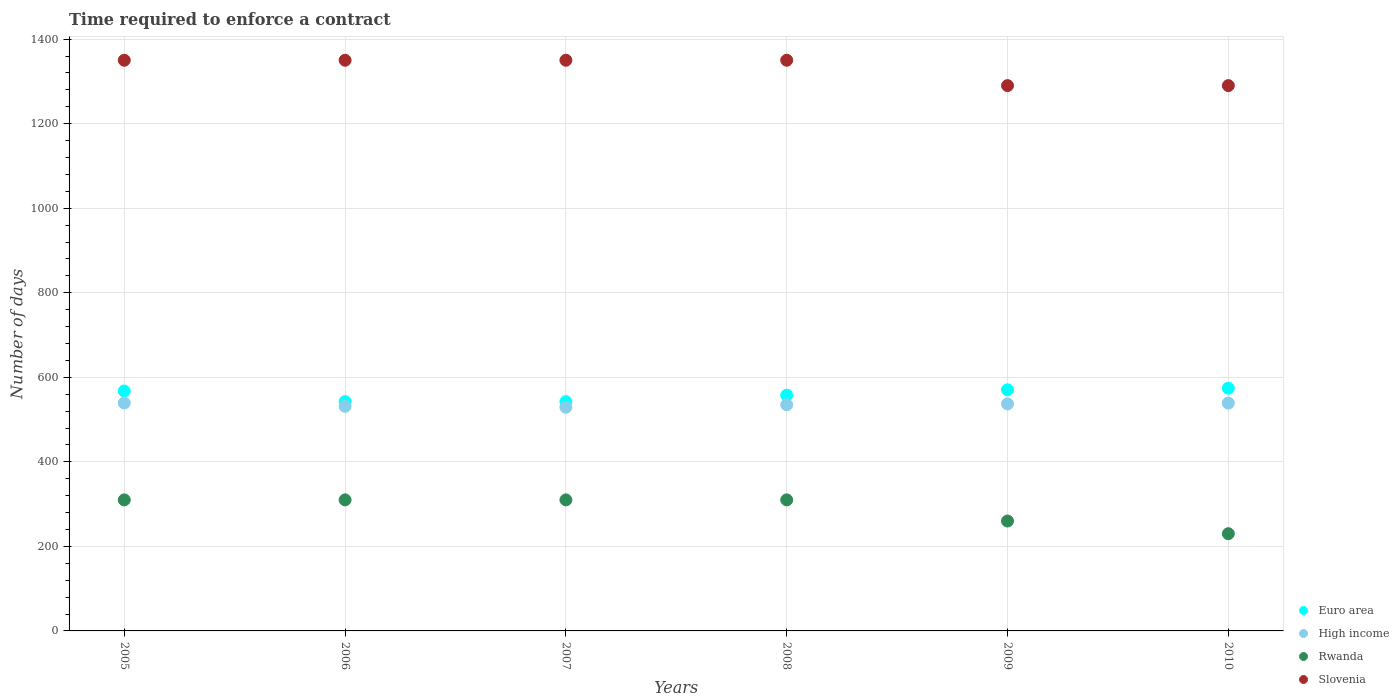Is the number of dotlines equal to the number of legend labels?
Provide a succinct answer. Yes. What is the number of days required to enforce a contract in Euro area in 2008?
Offer a terse response. 557.61. Across all years, what is the maximum number of days required to enforce a contract in Euro area?
Offer a very short reply. 574.28. Across all years, what is the minimum number of days required to enforce a contract in Euro area?
Ensure brevity in your answer.  542.41. In which year was the number of days required to enforce a contract in Rwanda minimum?
Your response must be concise. 2010. What is the total number of days required to enforce a contract in Rwanda in the graph?
Make the answer very short. 1730. What is the difference between the number of days required to enforce a contract in High income in 2005 and that in 2010?
Offer a very short reply. 0.27. What is the difference between the number of days required to enforce a contract in High income in 2010 and the number of days required to enforce a contract in Slovenia in 2008?
Make the answer very short. -811.04. What is the average number of days required to enforce a contract in Rwanda per year?
Offer a very short reply. 288.33. In the year 2006, what is the difference between the number of days required to enforce a contract in Euro area and number of days required to enforce a contract in Slovenia?
Give a very brief answer. -807.59. What is the ratio of the number of days required to enforce a contract in Euro area in 2009 to that in 2010?
Ensure brevity in your answer.  0.99. Is the difference between the number of days required to enforce a contract in Euro area in 2006 and 2010 greater than the difference between the number of days required to enforce a contract in Slovenia in 2006 and 2010?
Offer a very short reply. No. What is the difference between the highest and the second highest number of days required to enforce a contract in Euro area?
Your response must be concise. 3.89. What is the difference between the highest and the lowest number of days required to enforce a contract in Rwanda?
Provide a succinct answer. 80. In how many years, is the number of days required to enforce a contract in Slovenia greater than the average number of days required to enforce a contract in Slovenia taken over all years?
Give a very brief answer. 4. Is it the case that in every year, the sum of the number of days required to enforce a contract in Slovenia and number of days required to enforce a contract in Rwanda  is greater than the sum of number of days required to enforce a contract in Euro area and number of days required to enforce a contract in High income?
Give a very brief answer. No. Is the number of days required to enforce a contract in Rwanda strictly less than the number of days required to enforce a contract in High income over the years?
Offer a very short reply. Yes. What is the difference between two consecutive major ticks on the Y-axis?
Provide a succinct answer. 200. Are the values on the major ticks of Y-axis written in scientific E-notation?
Your response must be concise. No. Does the graph contain grids?
Keep it short and to the point. Yes. Where does the legend appear in the graph?
Provide a succinct answer. Bottom right. How many legend labels are there?
Provide a short and direct response. 4. How are the legend labels stacked?
Keep it short and to the point. Vertical. What is the title of the graph?
Ensure brevity in your answer.  Time required to enforce a contract. What is the label or title of the Y-axis?
Offer a very short reply. Number of days. What is the Number of days in Euro area in 2005?
Provide a succinct answer. 567.5. What is the Number of days in High income in 2005?
Give a very brief answer. 539.23. What is the Number of days of Rwanda in 2005?
Offer a terse response. 310. What is the Number of days in Slovenia in 2005?
Provide a succinct answer. 1350. What is the Number of days of Euro area in 2006?
Your answer should be very brief. 542.41. What is the Number of days in High income in 2006?
Give a very brief answer. 531.28. What is the Number of days in Rwanda in 2006?
Offer a terse response. 310. What is the Number of days in Slovenia in 2006?
Ensure brevity in your answer.  1350. What is the Number of days of Euro area in 2007?
Offer a very short reply. 542.41. What is the Number of days in High income in 2007?
Ensure brevity in your answer.  529.17. What is the Number of days in Rwanda in 2007?
Provide a short and direct response. 310. What is the Number of days of Slovenia in 2007?
Your response must be concise. 1350. What is the Number of days of Euro area in 2008?
Provide a succinct answer. 557.61. What is the Number of days in High income in 2008?
Your response must be concise. 535.04. What is the Number of days in Rwanda in 2008?
Ensure brevity in your answer.  310. What is the Number of days in Slovenia in 2008?
Offer a very short reply. 1350. What is the Number of days of Euro area in 2009?
Provide a short and direct response. 570.39. What is the Number of days in High income in 2009?
Offer a very short reply. 537.11. What is the Number of days of Rwanda in 2009?
Provide a succinct answer. 260. What is the Number of days in Slovenia in 2009?
Give a very brief answer. 1290. What is the Number of days of Euro area in 2010?
Provide a short and direct response. 574.28. What is the Number of days in High income in 2010?
Your answer should be compact. 538.96. What is the Number of days in Rwanda in 2010?
Ensure brevity in your answer.  230. What is the Number of days in Slovenia in 2010?
Your answer should be very brief. 1290. Across all years, what is the maximum Number of days of Euro area?
Make the answer very short. 574.28. Across all years, what is the maximum Number of days in High income?
Your answer should be compact. 539.23. Across all years, what is the maximum Number of days in Rwanda?
Provide a succinct answer. 310. Across all years, what is the maximum Number of days of Slovenia?
Ensure brevity in your answer.  1350. Across all years, what is the minimum Number of days of Euro area?
Keep it short and to the point. 542.41. Across all years, what is the minimum Number of days in High income?
Provide a succinct answer. 529.17. Across all years, what is the minimum Number of days of Rwanda?
Give a very brief answer. 230. Across all years, what is the minimum Number of days in Slovenia?
Provide a short and direct response. 1290. What is the total Number of days of Euro area in the graph?
Provide a succinct answer. 3354.6. What is the total Number of days in High income in the graph?
Give a very brief answer. 3210.79. What is the total Number of days of Rwanda in the graph?
Offer a very short reply. 1730. What is the total Number of days in Slovenia in the graph?
Give a very brief answer. 7980. What is the difference between the Number of days of Euro area in 2005 and that in 2006?
Provide a short and direct response. 25.09. What is the difference between the Number of days of High income in 2005 and that in 2006?
Make the answer very short. 7.95. What is the difference between the Number of days in Rwanda in 2005 and that in 2006?
Offer a very short reply. 0. What is the difference between the Number of days in Euro area in 2005 and that in 2007?
Make the answer very short. 25.09. What is the difference between the Number of days of High income in 2005 and that in 2007?
Your answer should be compact. 10.06. What is the difference between the Number of days in Rwanda in 2005 and that in 2007?
Offer a very short reply. 0. What is the difference between the Number of days of Slovenia in 2005 and that in 2007?
Your answer should be very brief. 0. What is the difference between the Number of days in Euro area in 2005 and that in 2008?
Provide a short and direct response. 9.89. What is the difference between the Number of days in High income in 2005 and that in 2008?
Ensure brevity in your answer.  4.19. What is the difference between the Number of days of Rwanda in 2005 and that in 2008?
Your answer should be compact. 0. What is the difference between the Number of days in Euro area in 2005 and that in 2009?
Your answer should be very brief. -2.89. What is the difference between the Number of days in High income in 2005 and that in 2009?
Provide a succinct answer. 2.12. What is the difference between the Number of days in Slovenia in 2005 and that in 2009?
Make the answer very short. 60. What is the difference between the Number of days in Euro area in 2005 and that in 2010?
Keep it short and to the point. -6.78. What is the difference between the Number of days in High income in 2005 and that in 2010?
Give a very brief answer. 0.27. What is the difference between the Number of days in Euro area in 2006 and that in 2007?
Provide a succinct answer. 0. What is the difference between the Number of days in High income in 2006 and that in 2007?
Make the answer very short. 2.11. What is the difference between the Number of days of Euro area in 2006 and that in 2008?
Offer a very short reply. -15.2. What is the difference between the Number of days of High income in 2006 and that in 2008?
Your response must be concise. -3.76. What is the difference between the Number of days of Slovenia in 2006 and that in 2008?
Your answer should be very brief. 0. What is the difference between the Number of days in Euro area in 2006 and that in 2009?
Provide a succinct answer. -27.98. What is the difference between the Number of days of High income in 2006 and that in 2009?
Your answer should be very brief. -5.83. What is the difference between the Number of days in Euro area in 2006 and that in 2010?
Keep it short and to the point. -31.87. What is the difference between the Number of days in High income in 2006 and that in 2010?
Offer a very short reply. -7.68. What is the difference between the Number of days in Euro area in 2007 and that in 2008?
Provide a succinct answer. -15.2. What is the difference between the Number of days in High income in 2007 and that in 2008?
Offer a terse response. -5.87. What is the difference between the Number of days of Slovenia in 2007 and that in 2008?
Your answer should be very brief. 0. What is the difference between the Number of days in Euro area in 2007 and that in 2009?
Offer a terse response. -27.98. What is the difference between the Number of days of High income in 2007 and that in 2009?
Your answer should be compact. -7.94. What is the difference between the Number of days in Slovenia in 2007 and that in 2009?
Offer a terse response. 60. What is the difference between the Number of days of Euro area in 2007 and that in 2010?
Offer a very short reply. -31.87. What is the difference between the Number of days of High income in 2007 and that in 2010?
Ensure brevity in your answer.  -9.79. What is the difference between the Number of days of Slovenia in 2007 and that in 2010?
Provide a short and direct response. 60. What is the difference between the Number of days in Euro area in 2008 and that in 2009?
Provide a short and direct response. -12.78. What is the difference between the Number of days in High income in 2008 and that in 2009?
Give a very brief answer. -2.07. What is the difference between the Number of days in Rwanda in 2008 and that in 2009?
Your answer should be very brief. 50. What is the difference between the Number of days in Slovenia in 2008 and that in 2009?
Your response must be concise. 60. What is the difference between the Number of days of Euro area in 2008 and that in 2010?
Your answer should be compact. -16.67. What is the difference between the Number of days of High income in 2008 and that in 2010?
Your answer should be very brief. -3.93. What is the difference between the Number of days of Euro area in 2009 and that in 2010?
Ensure brevity in your answer.  -3.89. What is the difference between the Number of days of High income in 2009 and that in 2010?
Keep it short and to the point. -1.85. What is the difference between the Number of days in Rwanda in 2009 and that in 2010?
Give a very brief answer. 30. What is the difference between the Number of days in Euro area in 2005 and the Number of days in High income in 2006?
Give a very brief answer. 36.22. What is the difference between the Number of days of Euro area in 2005 and the Number of days of Rwanda in 2006?
Ensure brevity in your answer.  257.5. What is the difference between the Number of days in Euro area in 2005 and the Number of days in Slovenia in 2006?
Your answer should be very brief. -782.5. What is the difference between the Number of days in High income in 2005 and the Number of days in Rwanda in 2006?
Your answer should be compact. 229.23. What is the difference between the Number of days of High income in 2005 and the Number of days of Slovenia in 2006?
Offer a very short reply. -810.77. What is the difference between the Number of days of Rwanda in 2005 and the Number of days of Slovenia in 2006?
Offer a very short reply. -1040. What is the difference between the Number of days of Euro area in 2005 and the Number of days of High income in 2007?
Provide a succinct answer. 38.33. What is the difference between the Number of days in Euro area in 2005 and the Number of days in Rwanda in 2007?
Ensure brevity in your answer.  257.5. What is the difference between the Number of days of Euro area in 2005 and the Number of days of Slovenia in 2007?
Your response must be concise. -782.5. What is the difference between the Number of days of High income in 2005 and the Number of days of Rwanda in 2007?
Ensure brevity in your answer.  229.23. What is the difference between the Number of days of High income in 2005 and the Number of days of Slovenia in 2007?
Ensure brevity in your answer.  -810.77. What is the difference between the Number of days in Rwanda in 2005 and the Number of days in Slovenia in 2007?
Ensure brevity in your answer.  -1040. What is the difference between the Number of days of Euro area in 2005 and the Number of days of High income in 2008?
Offer a terse response. 32.46. What is the difference between the Number of days of Euro area in 2005 and the Number of days of Rwanda in 2008?
Provide a succinct answer. 257.5. What is the difference between the Number of days in Euro area in 2005 and the Number of days in Slovenia in 2008?
Keep it short and to the point. -782.5. What is the difference between the Number of days of High income in 2005 and the Number of days of Rwanda in 2008?
Provide a short and direct response. 229.23. What is the difference between the Number of days of High income in 2005 and the Number of days of Slovenia in 2008?
Provide a short and direct response. -810.77. What is the difference between the Number of days of Rwanda in 2005 and the Number of days of Slovenia in 2008?
Ensure brevity in your answer.  -1040. What is the difference between the Number of days in Euro area in 2005 and the Number of days in High income in 2009?
Offer a terse response. 30.39. What is the difference between the Number of days in Euro area in 2005 and the Number of days in Rwanda in 2009?
Your answer should be very brief. 307.5. What is the difference between the Number of days in Euro area in 2005 and the Number of days in Slovenia in 2009?
Provide a short and direct response. -722.5. What is the difference between the Number of days in High income in 2005 and the Number of days in Rwanda in 2009?
Provide a short and direct response. 279.23. What is the difference between the Number of days in High income in 2005 and the Number of days in Slovenia in 2009?
Provide a succinct answer. -750.77. What is the difference between the Number of days of Rwanda in 2005 and the Number of days of Slovenia in 2009?
Keep it short and to the point. -980. What is the difference between the Number of days of Euro area in 2005 and the Number of days of High income in 2010?
Your response must be concise. 28.54. What is the difference between the Number of days of Euro area in 2005 and the Number of days of Rwanda in 2010?
Your answer should be very brief. 337.5. What is the difference between the Number of days of Euro area in 2005 and the Number of days of Slovenia in 2010?
Give a very brief answer. -722.5. What is the difference between the Number of days of High income in 2005 and the Number of days of Rwanda in 2010?
Your response must be concise. 309.23. What is the difference between the Number of days of High income in 2005 and the Number of days of Slovenia in 2010?
Provide a succinct answer. -750.77. What is the difference between the Number of days in Rwanda in 2005 and the Number of days in Slovenia in 2010?
Ensure brevity in your answer.  -980. What is the difference between the Number of days in Euro area in 2006 and the Number of days in High income in 2007?
Offer a terse response. 13.24. What is the difference between the Number of days in Euro area in 2006 and the Number of days in Rwanda in 2007?
Make the answer very short. 232.41. What is the difference between the Number of days of Euro area in 2006 and the Number of days of Slovenia in 2007?
Your answer should be very brief. -807.59. What is the difference between the Number of days in High income in 2006 and the Number of days in Rwanda in 2007?
Make the answer very short. 221.28. What is the difference between the Number of days in High income in 2006 and the Number of days in Slovenia in 2007?
Provide a short and direct response. -818.72. What is the difference between the Number of days of Rwanda in 2006 and the Number of days of Slovenia in 2007?
Your response must be concise. -1040. What is the difference between the Number of days of Euro area in 2006 and the Number of days of High income in 2008?
Your answer should be very brief. 7.37. What is the difference between the Number of days of Euro area in 2006 and the Number of days of Rwanda in 2008?
Your response must be concise. 232.41. What is the difference between the Number of days in Euro area in 2006 and the Number of days in Slovenia in 2008?
Make the answer very short. -807.59. What is the difference between the Number of days of High income in 2006 and the Number of days of Rwanda in 2008?
Give a very brief answer. 221.28. What is the difference between the Number of days in High income in 2006 and the Number of days in Slovenia in 2008?
Your answer should be compact. -818.72. What is the difference between the Number of days of Rwanda in 2006 and the Number of days of Slovenia in 2008?
Offer a terse response. -1040. What is the difference between the Number of days of Euro area in 2006 and the Number of days of High income in 2009?
Offer a very short reply. 5.3. What is the difference between the Number of days in Euro area in 2006 and the Number of days in Rwanda in 2009?
Provide a succinct answer. 282.41. What is the difference between the Number of days of Euro area in 2006 and the Number of days of Slovenia in 2009?
Give a very brief answer. -747.59. What is the difference between the Number of days of High income in 2006 and the Number of days of Rwanda in 2009?
Ensure brevity in your answer.  271.28. What is the difference between the Number of days in High income in 2006 and the Number of days in Slovenia in 2009?
Make the answer very short. -758.72. What is the difference between the Number of days in Rwanda in 2006 and the Number of days in Slovenia in 2009?
Ensure brevity in your answer.  -980. What is the difference between the Number of days in Euro area in 2006 and the Number of days in High income in 2010?
Offer a very short reply. 3.45. What is the difference between the Number of days of Euro area in 2006 and the Number of days of Rwanda in 2010?
Keep it short and to the point. 312.41. What is the difference between the Number of days in Euro area in 2006 and the Number of days in Slovenia in 2010?
Make the answer very short. -747.59. What is the difference between the Number of days in High income in 2006 and the Number of days in Rwanda in 2010?
Offer a terse response. 301.28. What is the difference between the Number of days of High income in 2006 and the Number of days of Slovenia in 2010?
Offer a terse response. -758.72. What is the difference between the Number of days of Rwanda in 2006 and the Number of days of Slovenia in 2010?
Offer a very short reply. -980. What is the difference between the Number of days in Euro area in 2007 and the Number of days in High income in 2008?
Make the answer very short. 7.37. What is the difference between the Number of days of Euro area in 2007 and the Number of days of Rwanda in 2008?
Offer a very short reply. 232.41. What is the difference between the Number of days of Euro area in 2007 and the Number of days of Slovenia in 2008?
Offer a terse response. -807.59. What is the difference between the Number of days of High income in 2007 and the Number of days of Rwanda in 2008?
Your response must be concise. 219.17. What is the difference between the Number of days of High income in 2007 and the Number of days of Slovenia in 2008?
Offer a very short reply. -820.83. What is the difference between the Number of days in Rwanda in 2007 and the Number of days in Slovenia in 2008?
Provide a short and direct response. -1040. What is the difference between the Number of days of Euro area in 2007 and the Number of days of High income in 2009?
Provide a short and direct response. 5.3. What is the difference between the Number of days of Euro area in 2007 and the Number of days of Rwanda in 2009?
Provide a short and direct response. 282.41. What is the difference between the Number of days in Euro area in 2007 and the Number of days in Slovenia in 2009?
Keep it short and to the point. -747.59. What is the difference between the Number of days of High income in 2007 and the Number of days of Rwanda in 2009?
Offer a very short reply. 269.17. What is the difference between the Number of days of High income in 2007 and the Number of days of Slovenia in 2009?
Your answer should be very brief. -760.83. What is the difference between the Number of days in Rwanda in 2007 and the Number of days in Slovenia in 2009?
Your answer should be compact. -980. What is the difference between the Number of days of Euro area in 2007 and the Number of days of High income in 2010?
Make the answer very short. 3.45. What is the difference between the Number of days in Euro area in 2007 and the Number of days in Rwanda in 2010?
Give a very brief answer. 312.41. What is the difference between the Number of days in Euro area in 2007 and the Number of days in Slovenia in 2010?
Make the answer very short. -747.59. What is the difference between the Number of days in High income in 2007 and the Number of days in Rwanda in 2010?
Your response must be concise. 299.17. What is the difference between the Number of days of High income in 2007 and the Number of days of Slovenia in 2010?
Your answer should be very brief. -760.83. What is the difference between the Number of days in Rwanda in 2007 and the Number of days in Slovenia in 2010?
Offer a terse response. -980. What is the difference between the Number of days in Euro area in 2008 and the Number of days in High income in 2009?
Make the answer very short. 20.5. What is the difference between the Number of days in Euro area in 2008 and the Number of days in Rwanda in 2009?
Give a very brief answer. 297.61. What is the difference between the Number of days of Euro area in 2008 and the Number of days of Slovenia in 2009?
Ensure brevity in your answer.  -732.39. What is the difference between the Number of days of High income in 2008 and the Number of days of Rwanda in 2009?
Make the answer very short. 275.04. What is the difference between the Number of days in High income in 2008 and the Number of days in Slovenia in 2009?
Make the answer very short. -754.96. What is the difference between the Number of days of Rwanda in 2008 and the Number of days of Slovenia in 2009?
Your response must be concise. -980. What is the difference between the Number of days in Euro area in 2008 and the Number of days in High income in 2010?
Provide a succinct answer. 18.65. What is the difference between the Number of days in Euro area in 2008 and the Number of days in Rwanda in 2010?
Give a very brief answer. 327.61. What is the difference between the Number of days in Euro area in 2008 and the Number of days in Slovenia in 2010?
Provide a succinct answer. -732.39. What is the difference between the Number of days in High income in 2008 and the Number of days in Rwanda in 2010?
Provide a short and direct response. 305.04. What is the difference between the Number of days of High income in 2008 and the Number of days of Slovenia in 2010?
Make the answer very short. -754.96. What is the difference between the Number of days of Rwanda in 2008 and the Number of days of Slovenia in 2010?
Provide a short and direct response. -980. What is the difference between the Number of days in Euro area in 2009 and the Number of days in High income in 2010?
Give a very brief answer. 31.43. What is the difference between the Number of days in Euro area in 2009 and the Number of days in Rwanda in 2010?
Offer a terse response. 340.39. What is the difference between the Number of days of Euro area in 2009 and the Number of days of Slovenia in 2010?
Make the answer very short. -719.61. What is the difference between the Number of days of High income in 2009 and the Number of days of Rwanda in 2010?
Offer a terse response. 307.11. What is the difference between the Number of days of High income in 2009 and the Number of days of Slovenia in 2010?
Offer a very short reply. -752.89. What is the difference between the Number of days in Rwanda in 2009 and the Number of days in Slovenia in 2010?
Make the answer very short. -1030. What is the average Number of days in Euro area per year?
Make the answer very short. 559.1. What is the average Number of days of High income per year?
Offer a very short reply. 535.13. What is the average Number of days in Rwanda per year?
Your answer should be compact. 288.33. What is the average Number of days of Slovenia per year?
Offer a very short reply. 1330. In the year 2005, what is the difference between the Number of days of Euro area and Number of days of High income?
Your answer should be very brief. 28.27. In the year 2005, what is the difference between the Number of days in Euro area and Number of days in Rwanda?
Provide a succinct answer. 257.5. In the year 2005, what is the difference between the Number of days in Euro area and Number of days in Slovenia?
Ensure brevity in your answer.  -782.5. In the year 2005, what is the difference between the Number of days of High income and Number of days of Rwanda?
Keep it short and to the point. 229.23. In the year 2005, what is the difference between the Number of days in High income and Number of days in Slovenia?
Provide a short and direct response. -810.77. In the year 2005, what is the difference between the Number of days in Rwanda and Number of days in Slovenia?
Give a very brief answer. -1040. In the year 2006, what is the difference between the Number of days in Euro area and Number of days in High income?
Ensure brevity in your answer.  11.13. In the year 2006, what is the difference between the Number of days of Euro area and Number of days of Rwanda?
Provide a short and direct response. 232.41. In the year 2006, what is the difference between the Number of days of Euro area and Number of days of Slovenia?
Offer a very short reply. -807.59. In the year 2006, what is the difference between the Number of days of High income and Number of days of Rwanda?
Offer a terse response. 221.28. In the year 2006, what is the difference between the Number of days in High income and Number of days in Slovenia?
Offer a very short reply. -818.72. In the year 2006, what is the difference between the Number of days of Rwanda and Number of days of Slovenia?
Your response must be concise. -1040. In the year 2007, what is the difference between the Number of days of Euro area and Number of days of High income?
Give a very brief answer. 13.24. In the year 2007, what is the difference between the Number of days of Euro area and Number of days of Rwanda?
Keep it short and to the point. 232.41. In the year 2007, what is the difference between the Number of days of Euro area and Number of days of Slovenia?
Offer a very short reply. -807.59. In the year 2007, what is the difference between the Number of days in High income and Number of days in Rwanda?
Give a very brief answer. 219.17. In the year 2007, what is the difference between the Number of days in High income and Number of days in Slovenia?
Provide a short and direct response. -820.83. In the year 2007, what is the difference between the Number of days in Rwanda and Number of days in Slovenia?
Your response must be concise. -1040. In the year 2008, what is the difference between the Number of days of Euro area and Number of days of High income?
Make the answer very short. 22.57. In the year 2008, what is the difference between the Number of days of Euro area and Number of days of Rwanda?
Offer a terse response. 247.61. In the year 2008, what is the difference between the Number of days in Euro area and Number of days in Slovenia?
Ensure brevity in your answer.  -792.39. In the year 2008, what is the difference between the Number of days in High income and Number of days in Rwanda?
Provide a succinct answer. 225.04. In the year 2008, what is the difference between the Number of days of High income and Number of days of Slovenia?
Provide a short and direct response. -814.96. In the year 2008, what is the difference between the Number of days of Rwanda and Number of days of Slovenia?
Provide a succinct answer. -1040. In the year 2009, what is the difference between the Number of days of Euro area and Number of days of High income?
Provide a succinct answer. 33.28. In the year 2009, what is the difference between the Number of days of Euro area and Number of days of Rwanda?
Keep it short and to the point. 310.39. In the year 2009, what is the difference between the Number of days of Euro area and Number of days of Slovenia?
Keep it short and to the point. -719.61. In the year 2009, what is the difference between the Number of days in High income and Number of days in Rwanda?
Offer a very short reply. 277.11. In the year 2009, what is the difference between the Number of days of High income and Number of days of Slovenia?
Ensure brevity in your answer.  -752.89. In the year 2009, what is the difference between the Number of days in Rwanda and Number of days in Slovenia?
Ensure brevity in your answer.  -1030. In the year 2010, what is the difference between the Number of days of Euro area and Number of days of High income?
Ensure brevity in your answer.  35.31. In the year 2010, what is the difference between the Number of days in Euro area and Number of days in Rwanda?
Offer a very short reply. 344.28. In the year 2010, what is the difference between the Number of days in Euro area and Number of days in Slovenia?
Provide a short and direct response. -715.72. In the year 2010, what is the difference between the Number of days of High income and Number of days of Rwanda?
Ensure brevity in your answer.  308.96. In the year 2010, what is the difference between the Number of days in High income and Number of days in Slovenia?
Offer a terse response. -751.04. In the year 2010, what is the difference between the Number of days in Rwanda and Number of days in Slovenia?
Your response must be concise. -1060. What is the ratio of the Number of days in Euro area in 2005 to that in 2006?
Your response must be concise. 1.05. What is the ratio of the Number of days in Slovenia in 2005 to that in 2006?
Keep it short and to the point. 1. What is the ratio of the Number of days in Euro area in 2005 to that in 2007?
Ensure brevity in your answer.  1.05. What is the ratio of the Number of days in Rwanda in 2005 to that in 2007?
Ensure brevity in your answer.  1. What is the ratio of the Number of days of Euro area in 2005 to that in 2008?
Provide a short and direct response. 1.02. What is the ratio of the Number of days of High income in 2005 to that in 2008?
Offer a terse response. 1.01. What is the ratio of the Number of days of Rwanda in 2005 to that in 2008?
Offer a very short reply. 1. What is the ratio of the Number of days in Slovenia in 2005 to that in 2008?
Your answer should be very brief. 1. What is the ratio of the Number of days in Rwanda in 2005 to that in 2009?
Offer a terse response. 1.19. What is the ratio of the Number of days of Slovenia in 2005 to that in 2009?
Provide a succinct answer. 1.05. What is the ratio of the Number of days in High income in 2005 to that in 2010?
Make the answer very short. 1. What is the ratio of the Number of days in Rwanda in 2005 to that in 2010?
Provide a succinct answer. 1.35. What is the ratio of the Number of days in Slovenia in 2005 to that in 2010?
Your answer should be very brief. 1.05. What is the ratio of the Number of days of High income in 2006 to that in 2007?
Provide a succinct answer. 1. What is the ratio of the Number of days of Euro area in 2006 to that in 2008?
Give a very brief answer. 0.97. What is the ratio of the Number of days of High income in 2006 to that in 2008?
Make the answer very short. 0.99. What is the ratio of the Number of days in Rwanda in 2006 to that in 2008?
Offer a terse response. 1. What is the ratio of the Number of days of Euro area in 2006 to that in 2009?
Your response must be concise. 0.95. What is the ratio of the Number of days in High income in 2006 to that in 2009?
Provide a short and direct response. 0.99. What is the ratio of the Number of days in Rwanda in 2006 to that in 2009?
Offer a very short reply. 1.19. What is the ratio of the Number of days in Slovenia in 2006 to that in 2009?
Make the answer very short. 1.05. What is the ratio of the Number of days in Euro area in 2006 to that in 2010?
Provide a short and direct response. 0.94. What is the ratio of the Number of days of High income in 2006 to that in 2010?
Offer a very short reply. 0.99. What is the ratio of the Number of days in Rwanda in 2006 to that in 2010?
Give a very brief answer. 1.35. What is the ratio of the Number of days in Slovenia in 2006 to that in 2010?
Ensure brevity in your answer.  1.05. What is the ratio of the Number of days in Euro area in 2007 to that in 2008?
Your answer should be compact. 0.97. What is the ratio of the Number of days in High income in 2007 to that in 2008?
Your answer should be very brief. 0.99. What is the ratio of the Number of days of Rwanda in 2007 to that in 2008?
Keep it short and to the point. 1. What is the ratio of the Number of days of Euro area in 2007 to that in 2009?
Your answer should be compact. 0.95. What is the ratio of the Number of days in High income in 2007 to that in 2009?
Provide a succinct answer. 0.99. What is the ratio of the Number of days of Rwanda in 2007 to that in 2009?
Provide a short and direct response. 1.19. What is the ratio of the Number of days of Slovenia in 2007 to that in 2009?
Give a very brief answer. 1.05. What is the ratio of the Number of days of Euro area in 2007 to that in 2010?
Offer a very short reply. 0.94. What is the ratio of the Number of days in High income in 2007 to that in 2010?
Your response must be concise. 0.98. What is the ratio of the Number of days of Rwanda in 2007 to that in 2010?
Offer a very short reply. 1.35. What is the ratio of the Number of days in Slovenia in 2007 to that in 2010?
Offer a terse response. 1.05. What is the ratio of the Number of days of Euro area in 2008 to that in 2009?
Provide a short and direct response. 0.98. What is the ratio of the Number of days in High income in 2008 to that in 2009?
Provide a short and direct response. 1. What is the ratio of the Number of days in Rwanda in 2008 to that in 2009?
Offer a very short reply. 1.19. What is the ratio of the Number of days in Slovenia in 2008 to that in 2009?
Keep it short and to the point. 1.05. What is the ratio of the Number of days of Euro area in 2008 to that in 2010?
Offer a very short reply. 0.97. What is the ratio of the Number of days in Rwanda in 2008 to that in 2010?
Provide a short and direct response. 1.35. What is the ratio of the Number of days in Slovenia in 2008 to that in 2010?
Offer a very short reply. 1.05. What is the ratio of the Number of days in Rwanda in 2009 to that in 2010?
Offer a very short reply. 1.13. What is the difference between the highest and the second highest Number of days in Euro area?
Give a very brief answer. 3.89. What is the difference between the highest and the second highest Number of days of High income?
Provide a short and direct response. 0.27. What is the difference between the highest and the lowest Number of days in Euro area?
Your answer should be compact. 31.87. What is the difference between the highest and the lowest Number of days of High income?
Your answer should be very brief. 10.06. What is the difference between the highest and the lowest Number of days in Rwanda?
Your response must be concise. 80. 